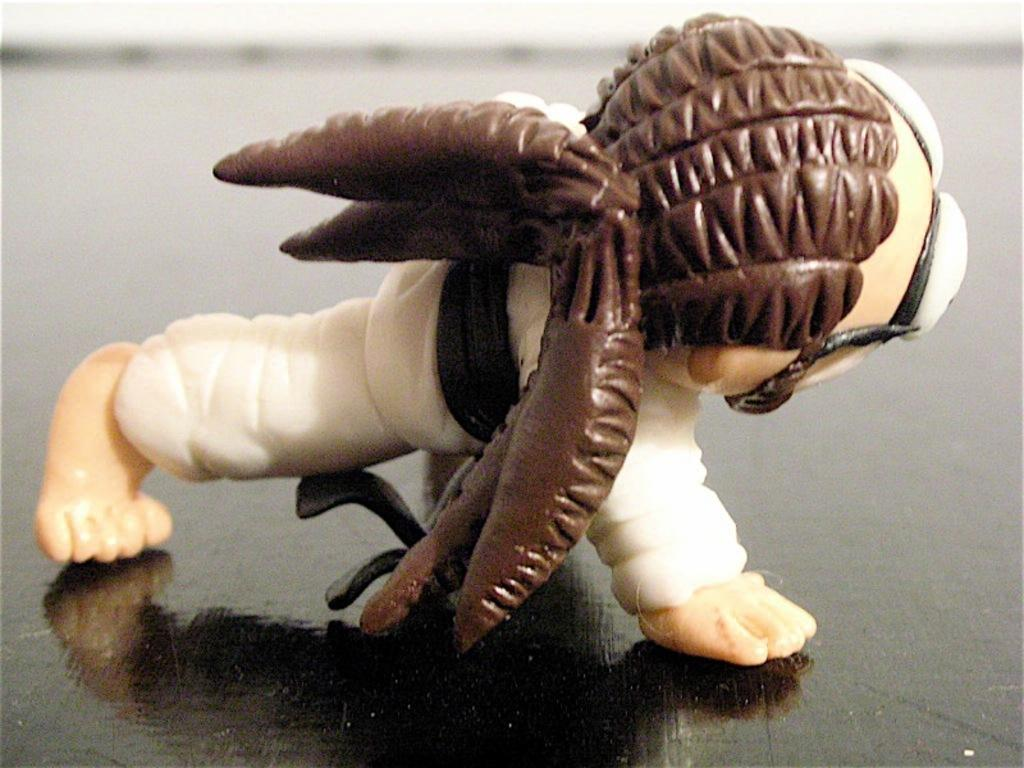What is the main object in the image? There is a toy in the image. Can you describe the colors of the toy? The toy has brown, white, black, and cream colors. What is the toy placed on in the image? The toy is on a black surface. What type of apple can be seen growing on the toy in the image? There is no apple present on the toy in the image. 